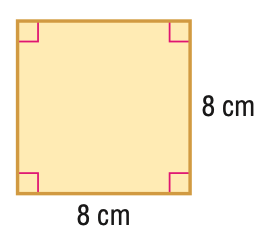Question: Find the perimeter of the figure.
Choices:
A. 8
B. 16
C. 32
D. 64
Answer with the letter. Answer: C Question: Find the area of the figure.
Choices:
A. 16
B. 32
C. 64
D. 128
Answer with the letter. Answer: C 